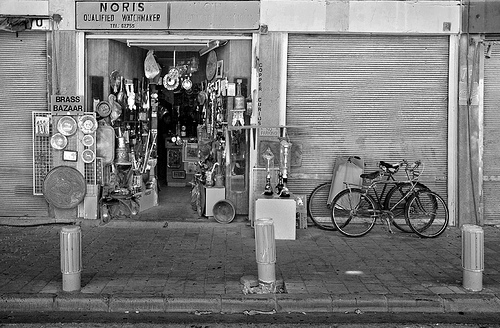Can you describe the bicycles? There are two bicycles; one has a traditional design with a basket at the front, while the other seems to be a road bike. Both are parked upright against a post. Do the bicycles seem like they belong to the shop? It's not possible to determine ownership from the image alone, but they could belong to customers or the shop owner, as they are parked outside the shop. 